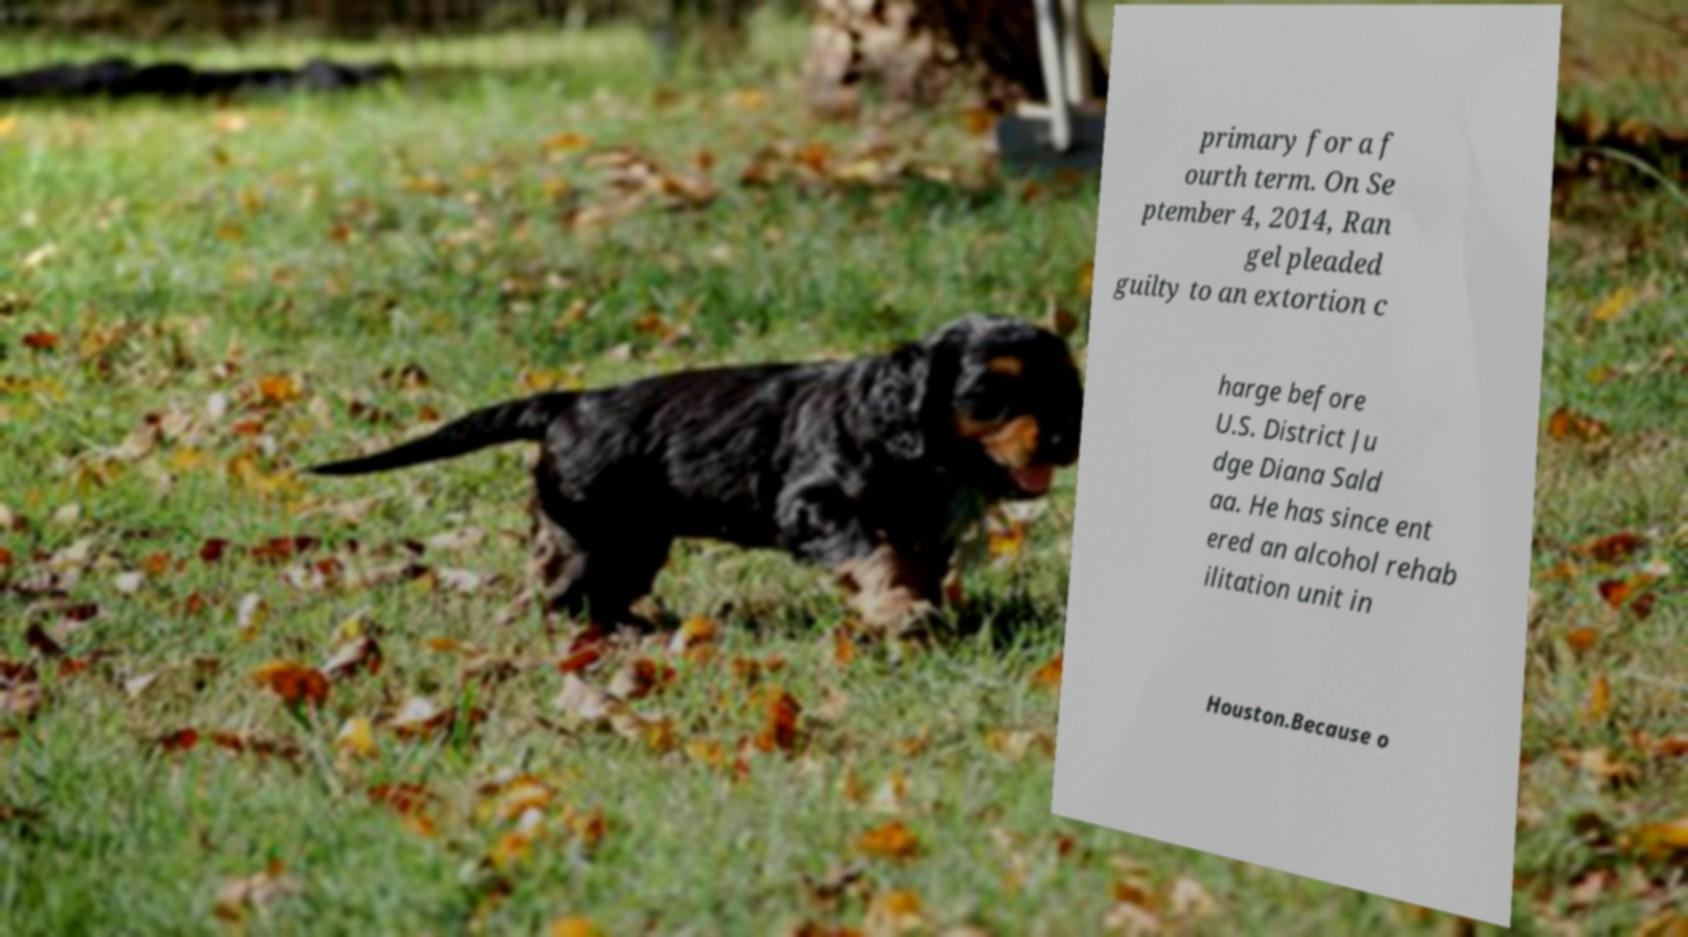Please identify and transcribe the text found in this image. primary for a f ourth term. On Se ptember 4, 2014, Ran gel pleaded guilty to an extortion c harge before U.S. District Ju dge Diana Sald aa. He has since ent ered an alcohol rehab ilitation unit in Houston.Because o 